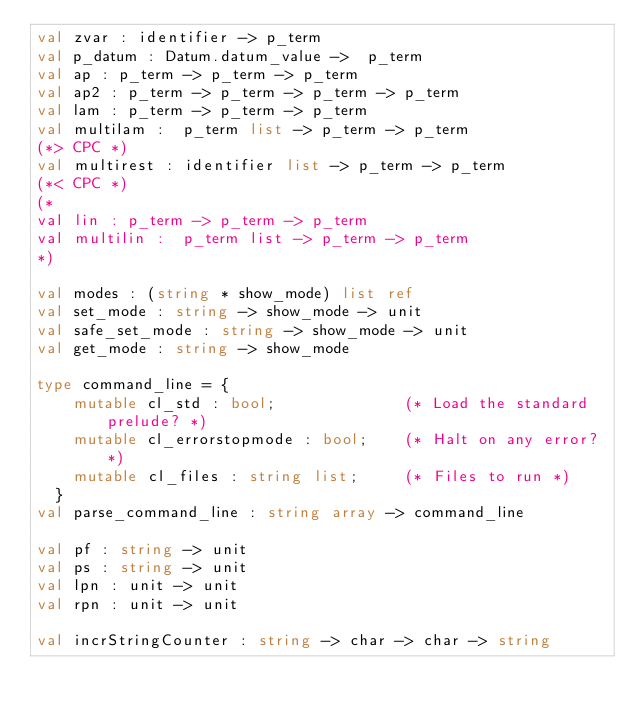Convert code to text. <code><loc_0><loc_0><loc_500><loc_500><_OCaml_>val zvar : identifier -> p_term
val p_datum : Datum.datum_value ->  p_term
val ap : p_term -> p_term -> p_term
val ap2 : p_term -> p_term -> p_term -> p_term
val lam : p_term -> p_term -> p_term
val multilam :  p_term list -> p_term -> p_term
(*> CPC *)
val multirest : identifier list -> p_term -> p_term
(*< CPC *)
(*
val lin : p_term -> p_term -> p_term
val multilin :  p_term list -> p_term -> p_term
*)

val modes : (string * show_mode) list ref
val set_mode : string -> show_mode -> unit
val safe_set_mode : string -> show_mode -> unit
val get_mode : string -> show_mode

type command_line = {
    mutable cl_std : bool;              (* Load the standard prelude? *)
    mutable cl_errorstopmode : bool;    (* Halt on any error? *)
    mutable cl_files : string list;     (* Files to run *)
  }
val parse_command_line : string array -> command_line

val pf : string -> unit
val ps : string -> unit
val lpn : unit -> unit
val rpn : unit -> unit

val incrStringCounter : string -> char -> char -> string
</code> 